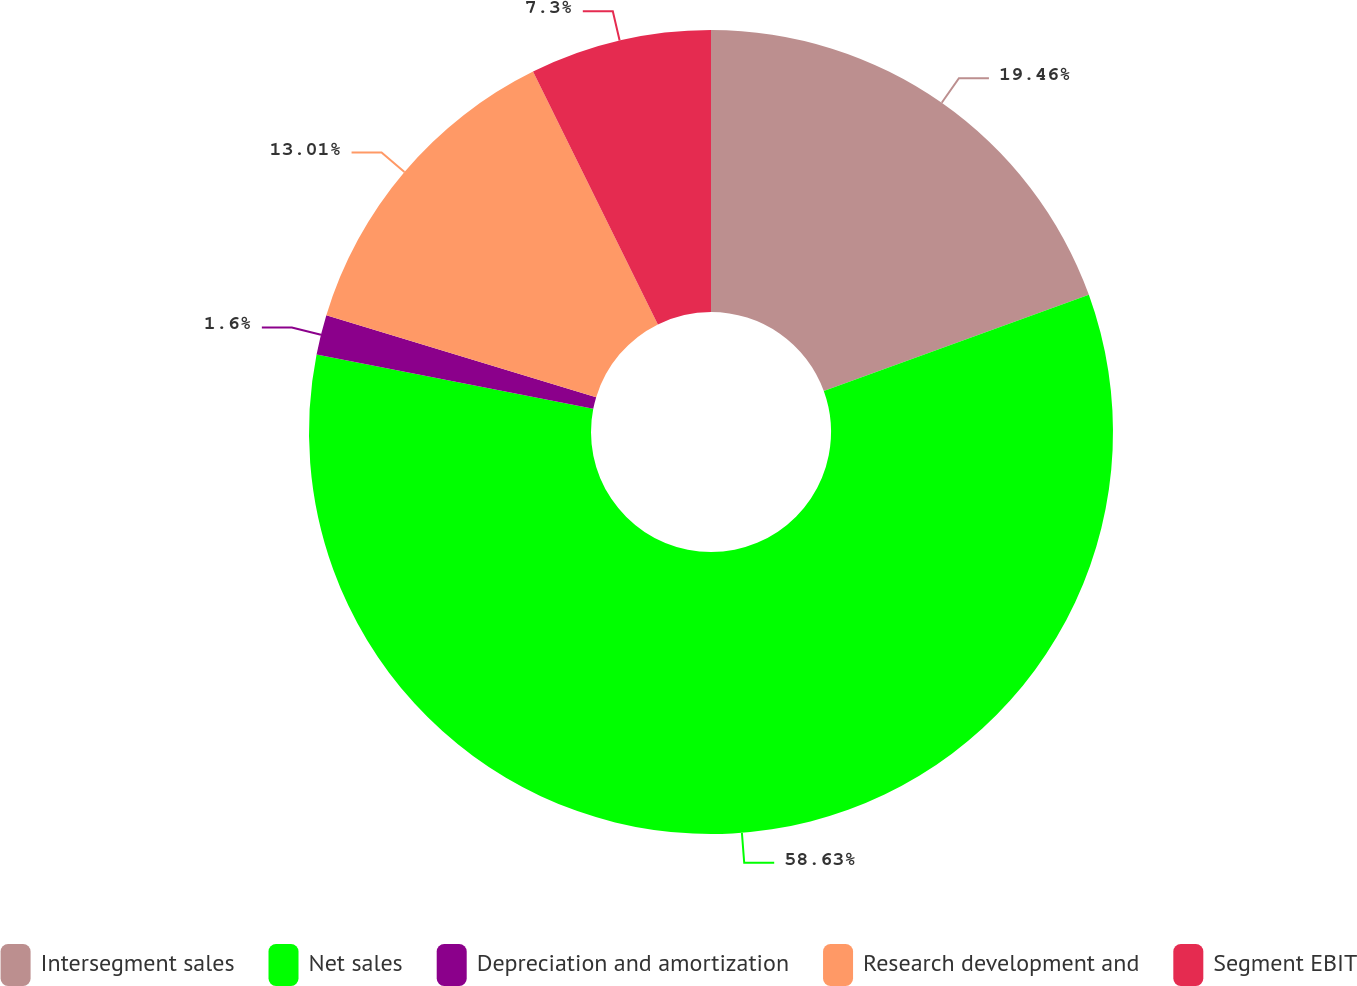Convert chart to OTSL. <chart><loc_0><loc_0><loc_500><loc_500><pie_chart><fcel>Intersegment sales<fcel>Net sales<fcel>Depreciation and amortization<fcel>Research development and<fcel>Segment EBIT<nl><fcel>19.46%<fcel>58.64%<fcel>1.6%<fcel>13.01%<fcel>7.3%<nl></chart> 